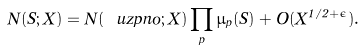Convert formula to latex. <formula><loc_0><loc_0><loc_500><loc_500>N ( S ; X ) = N ( \ u z p n o ; X ) \prod _ { p } \mu _ { p } ( S ) + O ( X ^ { 1 / 2 + \epsilon } ) .</formula> 